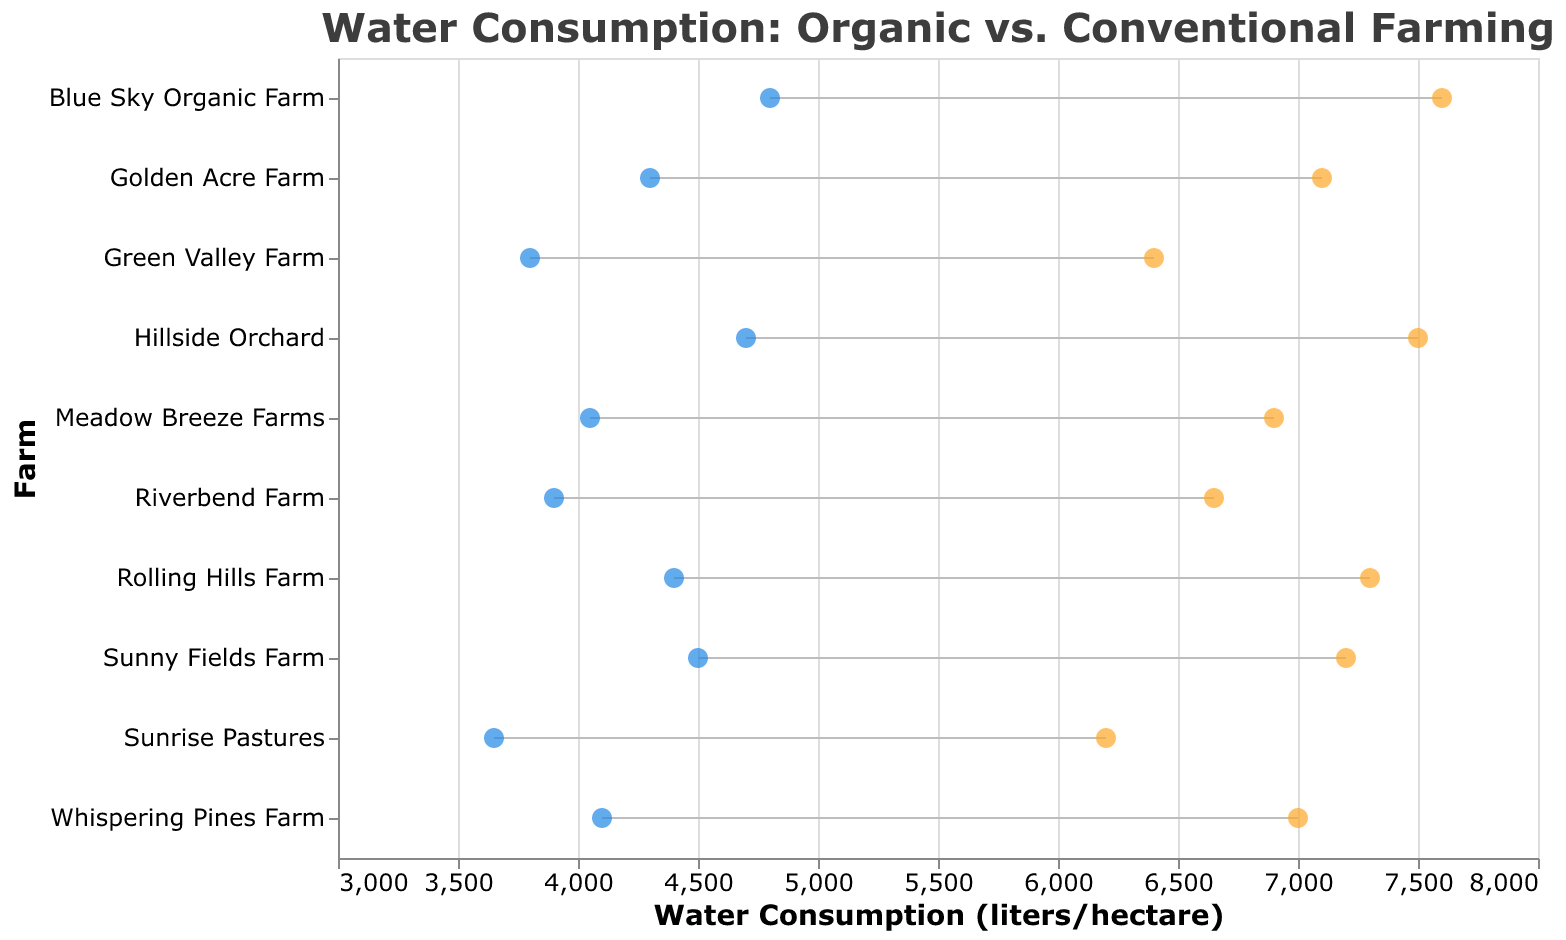What is the title of the figure? The title of the figure is displayed at the top and provides a summary of the data presented. By looking at the top of the plot, we can identify the title.
Answer: Water Consumption: Organic vs. Conventional Farming How many farms are included in the figure? The number of farms is equal to the number of unique entries (data points) shown along the y-axis, each representing a farm. By counting these entries, we can determine the total number of farms.
Answer: 10 Which farm has the lowest water consumption for organic farming? To find the farm with the lowest water consumption for organic farming, scan through the blue points (organic farming) and identify the farm associated with the point that is furthest to the left on the x-axis.
Answer: Sunrise Pastures What is the difference in water consumption between organic and conventional farming for Blue Sky Organic Farm? Locate Blue Sky Organic Farm on the y-axis. Then, look at the values for both organic (blue point) and conventional (orange point) farming aligned with this farm. Subtract the organic value from the conventional value.
Answer: 2800 liters/hectare On average, which type of farming consumes more water per hectare? Compare the positions of the blue points (organic) to the orange points (conventional) across all farms. Generally, if the orange points are further to the right, conventional farming uses more water. Compute the average water consumption for both.
Answer: Conventional farming Which farm shows the smallest difference in water usage between organic and conventional farming? To find the smallest difference, calculate the absolute difference between the blue and orange points for each farm. Identify the farm with the smallest difference.
Answer: Rolling Hills Farm What is the average water consumption for conventional farming across all farms in the figure? Sum the values of water consumption for conventional farming across all farms and then divide by the number of farms (10).
Answer: 6885 liters/hectare Are there any farms where organic farming uses more water than conventional farming? Look for farms where the blue point (representing organic farming) is further to the right on the x-axis compared to the orange point (representing conventional farming).
Answer: No Which farm has the highest water consumption for conventional farming? To identify the farm with the highest water consumption for conventional farming, find the orange point that is furthest to the right on the x-axis and note the corresponding farm.
Answer: Blue Sky Organic Farm How does the water consumption for organic farming at Meadow Breeze Farms compare to that at Riverbend Farm? Locate both Meadow Breeze Farms and Riverbend Farm on the y-axis. Compare the positions of their blue points (organic farming) across the x-axis to determine which is greater.
Answer: Meadow Breeze Farms consumes less water for organic farming than Riverbend Farm 